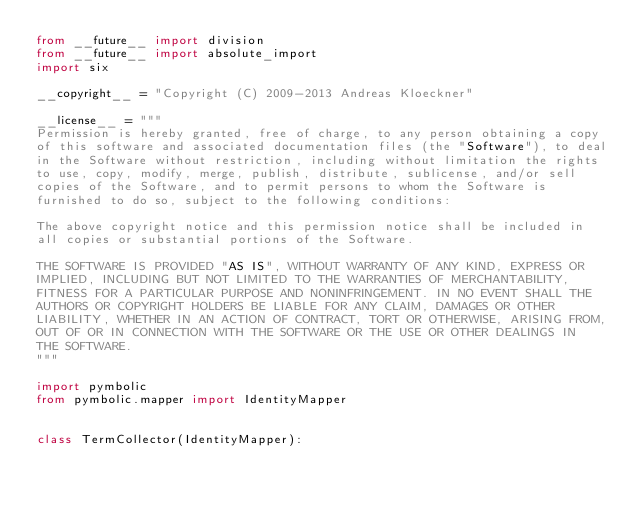<code> <loc_0><loc_0><loc_500><loc_500><_Python_>from __future__ import division
from __future__ import absolute_import
import six

__copyright__ = "Copyright (C) 2009-2013 Andreas Kloeckner"

__license__ = """
Permission is hereby granted, free of charge, to any person obtaining a copy
of this software and associated documentation files (the "Software"), to deal
in the Software without restriction, including without limitation the rights
to use, copy, modify, merge, publish, distribute, sublicense, and/or sell
copies of the Software, and to permit persons to whom the Software is
furnished to do so, subject to the following conditions:

The above copyright notice and this permission notice shall be included in
all copies or substantial portions of the Software.

THE SOFTWARE IS PROVIDED "AS IS", WITHOUT WARRANTY OF ANY KIND, EXPRESS OR
IMPLIED, INCLUDING BUT NOT LIMITED TO THE WARRANTIES OF MERCHANTABILITY,
FITNESS FOR A PARTICULAR PURPOSE AND NONINFRINGEMENT. IN NO EVENT SHALL THE
AUTHORS OR COPYRIGHT HOLDERS BE LIABLE FOR ANY CLAIM, DAMAGES OR OTHER
LIABILITY, WHETHER IN AN ACTION OF CONTRACT, TORT OR OTHERWISE, ARISING FROM,
OUT OF OR IN CONNECTION WITH THE SOFTWARE OR THE USE OR OTHER DEALINGS IN
THE SOFTWARE.
"""

import pymbolic
from pymbolic.mapper import IdentityMapper


class TermCollector(IdentityMapper):</code> 